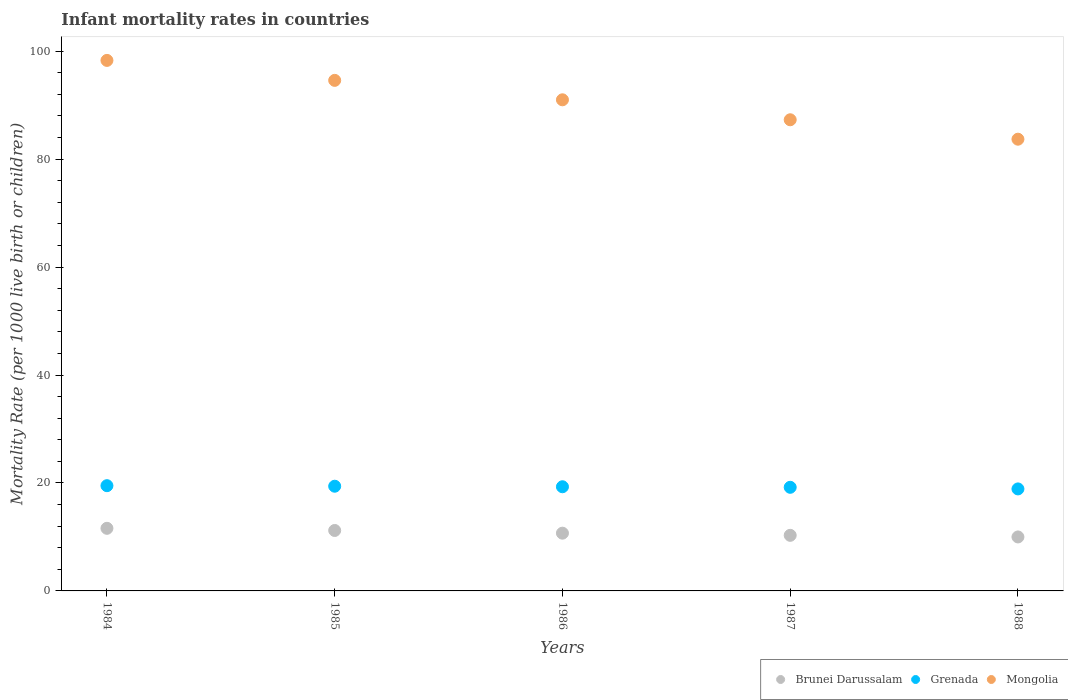How many different coloured dotlines are there?
Your answer should be compact. 3. What is the infant mortality rate in Grenada in 1986?
Give a very brief answer. 19.3. Across all years, what is the maximum infant mortality rate in Grenada?
Offer a very short reply. 19.5. In which year was the infant mortality rate in Grenada maximum?
Provide a succinct answer. 1984. In which year was the infant mortality rate in Grenada minimum?
Ensure brevity in your answer.  1988. What is the total infant mortality rate in Brunei Darussalam in the graph?
Offer a terse response. 53.8. What is the difference between the infant mortality rate in Brunei Darussalam in 1986 and that in 1987?
Make the answer very short. 0.4. What is the difference between the infant mortality rate in Brunei Darussalam in 1985 and the infant mortality rate in Grenada in 1986?
Provide a short and direct response. -8.1. What is the average infant mortality rate in Mongolia per year?
Provide a short and direct response. 90.98. In the year 1986, what is the difference between the infant mortality rate in Brunei Darussalam and infant mortality rate in Mongolia?
Offer a terse response. -80.3. What is the ratio of the infant mortality rate in Grenada in 1984 to that in 1986?
Offer a terse response. 1.01. Is the difference between the infant mortality rate in Brunei Darussalam in 1985 and 1986 greater than the difference between the infant mortality rate in Mongolia in 1985 and 1986?
Offer a terse response. No. What is the difference between the highest and the second highest infant mortality rate in Grenada?
Provide a short and direct response. 0.1. What is the difference between the highest and the lowest infant mortality rate in Mongolia?
Offer a very short reply. 14.6. In how many years, is the infant mortality rate in Brunei Darussalam greater than the average infant mortality rate in Brunei Darussalam taken over all years?
Provide a succinct answer. 2. Is the sum of the infant mortality rate in Mongolia in 1984 and 1985 greater than the maximum infant mortality rate in Grenada across all years?
Give a very brief answer. Yes. Is it the case that in every year, the sum of the infant mortality rate in Mongolia and infant mortality rate in Grenada  is greater than the infant mortality rate in Brunei Darussalam?
Provide a succinct answer. Yes. Does the infant mortality rate in Brunei Darussalam monotonically increase over the years?
Your response must be concise. No. How many dotlines are there?
Keep it short and to the point. 3. What is the difference between two consecutive major ticks on the Y-axis?
Provide a short and direct response. 20. Does the graph contain any zero values?
Offer a very short reply. No. Does the graph contain grids?
Provide a short and direct response. No. Where does the legend appear in the graph?
Provide a short and direct response. Bottom right. What is the title of the graph?
Make the answer very short. Infant mortality rates in countries. What is the label or title of the Y-axis?
Provide a short and direct response. Mortality Rate (per 1000 live birth or children). What is the Mortality Rate (per 1000 live birth or children) of Grenada in 1984?
Offer a very short reply. 19.5. What is the Mortality Rate (per 1000 live birth or children) of Mongolia in 1984?
Offer a very short reply. 98.3. What is the Mortality Rate (per 1000 live birth or children) of Brunei Darussalam in 1985?
Offer a terse response. 11.2. What is the Mortality Rate (per 1000 live birth or children) in Mongolia in 1985?
Provide a succinct answer. 94.6. What is the Mortality Rate (per 1000 live birth or children) of Grenada in 1986?
Give a very brief answer. 19.3. What is the Mortality Rate (per 1000 live birth or children) in Mongolia in 1986?
Offer a terse response. 91. What is the Mortality Rate (per 1000 live birth or children) of Mongolia in 1987?
Provide a succinct answer. 87.3. What is the Mortality Rate (per 1000 live birth or children) in Brunei Darussalam in 1988?
Offer a terse response. 10. What is the Mortality Rate (per 1000 live birth or children) in Grenada in 1988?
Offer a terse response. 18.9. What is the Mortality Rate (per 1000 live birth or children) of Mongolia in 1988?
Your response must be concise. 83.7. Across all years, what is the maximum Mortality Rate (per 1000 live birth or children) of Brunei Darussalam?
Your answer should be very brief. 11.6. Across all years, what is the maximum Mortality Rate (per 1000 live birth or children) of Mongolia?
Your answer should be compact. 98.3. Across all years, what is the minimum Mortality Rate (per 1000 live birth or children) in Mongolia?
Give a very brief answer. 83.7. What is the total Mortality Rate (per 1000 live birth or children) of Brunei Darussalam in the graph?
Provide a succinct answer. 53.8. What is the total Mortality Rate (per 1000 live birth or children) in Grenada in the graph?
Keep it short and to the point. 96.3. What is the total Mortality Rate (per 1000 live birth or children) of Mongolia in the graph?
Your response must be concise. 454.9. What is the difference between the Mortality Rate (per 1000 live birth or children) of Grenada in 1984 and that in 1985?
Offer a very short reply. 0.1. What is the difference between the Mortality Rate (per 1000 live birth or children) of Brunei Darussalam in 1984 and that in 1986?
Offer a very short reply. 0.9. What is the difference between the Mortality Rate (per 1000 live birth or children) in Grenada in 1984 and that in 1986?
Your answer should be compact. 0.2. What is the difference between the Mortality Rate (per 1000 live birth or children) of Mongolia in 1984 and that in 1986?
Provide a succinct answer. 7.3. What is the difference between the Mortality Rate (per 1000 live birth or children) of Brunei Darussalam in 1984 and that in 1987?
Offer a very short reply. 1.3. What is the difference between the Mortality Rate (per 1000 live birth or children) of Grenada in 1984 and that in 1987?
Give a very brief answer. 0.3. What is the difference between the Mortality Rate (per 1000 live birth or children) in Brunei Darussalam in 1984 and that in 1988?
Offer a terse response. 1.6. What is the difference between the Mortality Rate (per 1000 live birth or children) of Mongolia in 1984 and that in 1988?
Give a very brief answer. 14.6. What is the difference between the Mortality Rate (per 1000 live birth or children) of Brunei Darussalam in 1985 and that in 1986?
Keep it short and to the point. 0.5. What is the difference between the Mortality Rate (per 1000 live birth or children) of Grenada in 1985 and that in 1986?
Your answer should be very brief. 0.1. What is the difference between the Mortality Rate (per 1000 live birth or children) in Mongolia in 1985 and that in 1986?
Your answer should be compact. 3.6. What is the difference between the Mortality Rate (per 1000 live birth or children) of Grenada in 1985 and that in 1987?
Your answer should be compact. 0.2. What is the difference between the Mortality Rate (per 1000 live birth or children) of Mongolia in 1985 and that in 1987?
Your answer should be very brief. 7.3. What is the difference between the Mortality Rate (per 1000 live birth or children) in Brunei Darussalam in 1985 and that in 1988?
Offer a terse response. 1.2. What is the difference between the Mortality Rate (per 1000 live birth or children) in Grenada in 1985 and that in 1988?
Keep it short and to the point. 0.5. What is the difference between the Mortality Rate (per 1000 live birth or children) of Mongolia in 1985 and that in 1988?
Provide a short and direct response. 10.9. What is the difference between the Mortality Rate (per 1000 live birth or children) of Brunei Darussalam in 1986 and that in 1987?
Give a very brief answer. 0.4. What is the difference between the Mortality Rate (per 1000 live birth or children) in Grenada in 1986 and that in 1987?
Keep it short and to the point. 0.1. What is the difference between the Mortality Rate (per 1000 live birth or children) in Brunei Darussalam in 1986 and that in 1988?
Keep it short and to the point. 0.7. What is the difference between the Mortality Rate (per 1000 live birth or children) in Grenada in 1986 and that in 1988?
Your answer should be very brief. 0.4. What is the difference between the Mortality Rate (per 1000 live birth or children) of Brunei Darussalam in 1987 and that in 1988?
Keep it short and to the point. 0.3. What is the difference between the Mortality Rate (per 1000 live birth or children) in Mongolia in 1987 and that in 1988?
Keep it short and to the point. 3.6. What is the difference between the Mortality Rate (per 1000 live birth or children) in Brunei Darussalam in 1984 and the Mortality Rate (per 1000 live birth or children) in Grenada in 1985?
Offer a very short reply. -7.8. What is the difference between the Mortality Rate (per 1000 live birth or children) of Brunei Darussalam in 1984 and the Mortality Rate (per 1000 live birth or children) of Mongolia in 1985?
Offer a terse response. -83. What is the difference between the Mortality Rate (per 1000 live birth or children) of Grenada in 1984 and the Mortality Rate (per 1000 live birth or children) of Mongolia in 1985?
Keep it short and to the point. -75.1. What is the difference between the Mortality Rate (per 1000 live birth or children) of Brunei Darussalam in 1984 and the Mortality Rate (per 1000 live birth or children) of Mongolia in 1986?
Your answer should be very brief. -79.4. What is the difference between the Mortality Rate (per 1000 live birth or children) in Grenada in 1984 and the Mortality Rate (per 1000 live birth or children) in Mongolia in 1986?
Make the answer very short. -71.5. What is the difference between the Mortality Rate (per 1000 live birth or children) in Brunei Darussalam in 1984 and the Mortality Rate (per 1000 live birth or children) in Grenada in 1987?
Your response must be concise. -7.6. What is the difference between the Mortality Rate (per 1000 live birth or children) in Brunei Darussalam in 1984 and the Mortality Rate (per 1000 live birth or children) in Mongolia in 1987?
Give a very brief answer. -75.7. What is the difference between the Mortality Rate (per 1000 live birth or children) of Grenada in 1984 and the Mortality Rate (per 1000 live birth or children) of Mongolia in 1987?
Your answer should be compact. -67.8. What is the difference between the Mortality Rate (per 1000 live birth or children) in Brunei Darussalam in 1984 and the Mortality Rate (per 1000 live birth or children) in Mongolia in 1988?
Your answer should be very brief. -72.1. What is the difference between the Mortality Rate (per 1000 live birth or children) of Grenada in 1984 and the Mortality Rate (per 1000 live birth or children) of Mongolia in 1988?
Make the answer very short. -64.2. What is the difference between the Mortality Rate (per 1000 live birth or children) in Brunei Darussalam in 1985 and the Mortality Rate (per 1000 live birth or children) in Mongolia in 1986?
Your response must be concise. -79.8. What is the difference between the Mortality Rate (per 1000 live birth or children) in Grenada in 1985 and the Mortality Rate (per 1000 live birth or children) in Mongolia in 1986?
Offer a very short reply. -71.6. What is the difference between the Mortality Rate (per 1000 live birth or children) of Brunei Darussalam in 1985 and the Mortality Rate (per 1000 live birth or children) of Grenada in 1987?
Provide a short and direct response. -8. What is the difference between the Mortality Rate (per 1000 live birth or children) in Brunei Darussalam in 1985 and the Mortality Rate (per 1000 live birth or children) in Mongolia in 1987?
Offer a terse response. -76.1. What is the difference between the Mortality Rate (per 1000 live birth or children) of Grenada in 1985 and the Mortality Rate (per 1000 live birth or children) of Mongolia in 1987?
Your response must be concise. -67.9. What is the difference between the Mortality Rate (per 1000 live birth or children) of Brunei Darussalam in 1985 and the Mortality Rate (per 1000 live birth or children) of Mongolia in 1988?
Your response must be concise. -72.5. What is the difference between the Mortality Rate (per 1000 live birth or children) in Grenada in 1985 and the Mortality Rate (per 1000 live birth or children) in Mongolia in 1988?
Offer a terse response. -64.3. What is the difference between the Mortality Rate (per 1000 live birth or children) of Brunei Darussalam in 1986 and the Mortality Rate (per 1000 live birth or children) of Grenada in 1987?
Ensure brevity in your answer.  -8.5. What is the difference between the Mortality Rate (per 1000 live birth or children) in Brunei Darussalam in 1986 and the Mortality Rate (per 1000 live birth or children) in Mongolia in 1987?
Offer a terse response. -76.6. What is the difference between the Mortality Rate (per 1000 live birth or children) in Grenada in 1986 and the Mortality Rate (per 1000 live birth or children) in Mongolia in 1987?
Provide a succinct answer. -68. What is the difference between the Mortality Rate (per 1000 live birth or children) in Brunei Darussalam in 1986 and the Mortality Rate (per 1000 live birth or children) in Mongolia in 1988?
Your answer should be very brief. -73. What is the difference between the Mortality Rate (per 1000 live birth or children) of Grenada in 1986 and the Mortality Rate (per 1000 live birth or children) of Mongolia in 1988?
Ensure brevity in your answer.  -64.4. What is the difference between the Mortality Rate (per 1000 live birth or children) of Brunei Darussalam in 1987 and the Mortality Rate (per 1000 live birth or children) of Mongolia in 1988?
Offer a terse response. -73.4. What is the difference between the Mortality Rate (per 1000 live birth or children) of Grenada in 1987 and the Mortality Rate (per 1000 live birth or children) of Mongolia in 1988?
Ensure brevity in your answer.  -64.5. What is the average Mortality Rate (per 1000 live birth or children) of Brunei Darussalam per year?
Offer a terse response. 10.76. What is the average Mortality Rate (per 1000 live birth or children) in Grenada per year?
Make the answer very short. 19.26. What is the average Mortality Rate (per 1000 live birth or children) of Mongolia per year?
Ensure brevity in your answer.  90.98. In the year 1984, what is the difference between the Mortality Rate (per 1000 live birth or children) in Brunei Darussalam and Mortality Rate (per 1000 live birth or children) in Grenada?
Keep it short and to the point. -7.9. In the year 1984, what is the difference between the Mortality Rate (per 1000 live birth or children) in Brunei Darussalam and Mortality Rate (per 1000 live birth or children) in Mongolia?
Ensure brevity in your answer.  -86.7. In the year 1984, what is the difference between the Mortality Rate (per 1000 live birth or children) of Grenada and Mortality Rate (per 1000 live birth or children) of Mongolia?
Offer a very short reply. -78.8. In the year 1985, what is the difference between the Mortality Rate (per 1000 live birth or children) of Brunei Darussalam and Mortality Rate (per 1000 live birth or children) of Mongolia?
Make the answer very short. -83.4. In the year 1985, what is the difference between the Mortality Rate (per 1000 live birth or children) of Grenada and Mortality Rate (per 1000 live birth or children) of Mongolia?
Ensure brevity in your answer.  -75.2. In the year 1986, what is the difference between the Mortality Rate (per 1000 live birth or children) in Brunei Darussalam and Mortality Rate (per 1000 live birth or children) in Grenada?
Ensure brevity in your answer.  -8.6. In the year 1986, what is the difference between the Mortality Rate (per 1000 live birth or children) of Brunei Darussalam and Mortality Rate (per 1000 live birth or children) of Mongolia?
Your answer should be compact. -80.3. In the year 1986, what is the difference between the Mortality Rate (per 1000 live birth or children) of Grenada and Mortality Rate (per 1000 live birth or children) of Mongolia?
Your answer should be very brief. -71.7. In the year 1987, what is the difference between the Mortality Rate (per 1000 live birth or children) in Brunei Darussalam and Mortality Rate (per 1000 live birth or children) in Grenada?
Offer a terse response. -8.9. In the year 1987, what is the difference between the Mortality Rate (per 1000 live birth or children) of Brunei Darussalam and Mortality Rate (per 1000 live birth or children) of Mongolia?
Offer a terse response. -77. In the year 1987, what is the difference between the Mortality Rate (per 1000 live birth or children) in Grenada and Mortality Rate (per 1000 live birth or children) in Mongolia?
Your answer should be very brief. -68.1. In the year 1988, what is the difference between the Mortality Rate (per 1000 live birth or children) of Brunei Darussalam and Mortality Rate (per 1000 live birth or children) of Grenada?
Provide a short and direct response. -8.9. In the year 1988, what is the difference between the Mortality Rate (per 1000 live birth or children) of Brunei Darussalam and Mortality Rate (per 1000 live birth or children) of Mongolia?
Offer a very short reply. -73.7. In the year 1988, what is the difference between the Mortality Rate (per 1000 live birth or children) of Grenada and Mortality Rate (per 1000 live birth or children) of Mongolia?
Your answer should be compact. -64.8. What is the ratio of the Mortality Rate (per 1000 live birth or children) of Brunei Darussalam in 1984 to that in 1985?
Provide a short and direct response. 1.04. What is the ratio of the Mortality Rate (per 1000 live birth or children) of Mongolia in 1984 to that in 1985?
Your response must be concise. 1.04. What is the ratio of the Mortality Rate (per 1000 live birth or children) of Brunei Darussalam in 1984 to that in 1986?
Offer a very short reply. 1.08. What is the ratio of the Mortality Rate (per 1000 live birth or children) in Grenada in 1984 to that in 1986?
Offer a terse response. 1.01. What is the ratio of the Mortality Rate (per 1000 live birth or children) of Mongolia in 1984 to that in 1986?
Offer a very short reply. 1.08. What is the ratio of the Mortality Rate (per 1000 live birth or children) in Brunei Darussalam in 1984 to that in 1987?
Make the answer very short. 1.13. What is the ratio of the Mortality Rate (per 1000 live birth or children) in Grenada in 1984 to that in 1987?
Ensure brevity in your answer.  1.02. What is the ratio of the Mortality Rate (per 1000 live birth or children) in Mongolia in 1984 to that in 1987?
Your response must be concise. 1.13. What is the ratio of the Mortality Rate (per 1000 live birth or children) in Brunei Darussalam in 1984 to that in 1988?
Your response must be concise. 1.16. What is the ratio of the Mortality Rate (per 1000 live birth or children) in Grenada in 1984 to that in 1988?
Make the answer very short. 1.03. What is the ratio of the Mortality Rate (per 1000 live birth or children) of Mongolia in 1984 to that in 1988?
Keep it short and to the point. 1.17. What is the ratio of the Mortality Rate (per 1000 live birth or children) in Brunei Darussalam in 1985 to that in 1986?
Your answer should be compact. 1.05. What is the ratio of the Mortality Rate (per 1000 live birth or children) of Grenada in 1985 to that in 1986?
Provide a short and direct response. 1.01. What is the ratio of the Mortality Rate (per 1000 live birth or children) of Mongolia in 1985 to that in 1986?
Your response must be concise. 1.04. What is the ratio of the Mortality Rate (per 1000 live birth or children) in Brunei Darussalam in 1985 to that in 1987?
Offer a very short reply. 1.09. What is the ratio of the Mortality Rate (per 1000 live birth or children) of Grenada in 1985 to that in 1987?
Your answer should be compact. 1.01. What is the ratio of the Mortality Rate (per 1000 live birth or children) in Mongolia in 1985 to that in 1987?
Offer a very short reply. 1.08. What is the ratio of the Mortality Rate (per 1000 live birth or children) in Brunei Darussalam in 1985 to that in 1988?
Offer a terse response. 1.12. What is the ratio of the Mortality Rate (per 1000 live birth or children) of Grenada in 1985 to that in 1988?
Ensure brevity in your answer.  1.03. What is the ratio of the Mortality Rate (per 1000 live birth or children) in Mongolia in 1985 to that in 1988?
Your response must be concise. 1.13. What is the ratio of the Mortality Rate (per 1000 live birth or children) of Brunei Darussalam in 1986 to that in 1987?
Your answer should be very brief. 1.04. What is the ratio of the Mortality Rate (per 1000 live birth or children) of Mongolia in 1986 to that in 1987?
Give a very brief answer. 1.04. What is the ratio of the Mortality Rate (per 1000 live birth or children) of Brunei Darussalam in 1986 to that in 1988?
Offer a very short reply. 1.07. What is the ratio of the Mortality Rate (per 1000 live birth or children) in Grenada in 1986 to that in 1988?
Your answer should be compact. 1.02. What is the ratio of the Mortality Rate (per 1000 live birth or children) in Mongolia in 1986 to that in 1988?
Make the answer very short. 1.09. What is the ratio of the Mortality Rate (per 1000 live birth or children) of Brunei Darussalam in 1987 to that in 1988?
Give a very brief answer. 1.03. What is the ratio of the Mortality Rate (per 1000 live birth or children) of Grenada in 1987 to that in 1988?
Your answer should be very brief. 1.02. What is the ratio of the Mortality Rate (per 1000 live birth or children) of Mongolia in 1987 to that in 1988?
Your answer should be very brief. 1.04. What is the difference between the highest and the second highest Mortality Rate (per 1000 live birth or children) in Mongolia?
Offer a terse response. 3.7. What is the difference between the highest and the lowest Mortality Rate (per 1000 live birth or children) in Brunei Darussalam?
Offer a terse response. 1.6. What is the difference between the highest and the lowest Mortality Rate (per 1000 live birth or children) of Grenada?
Make the answer very short. 0.6. What is the difference between the highest and the lowest Mortality Rate (per 1000 live birth or children) in Mongolia?
Your answer should be compact. 14.6. 